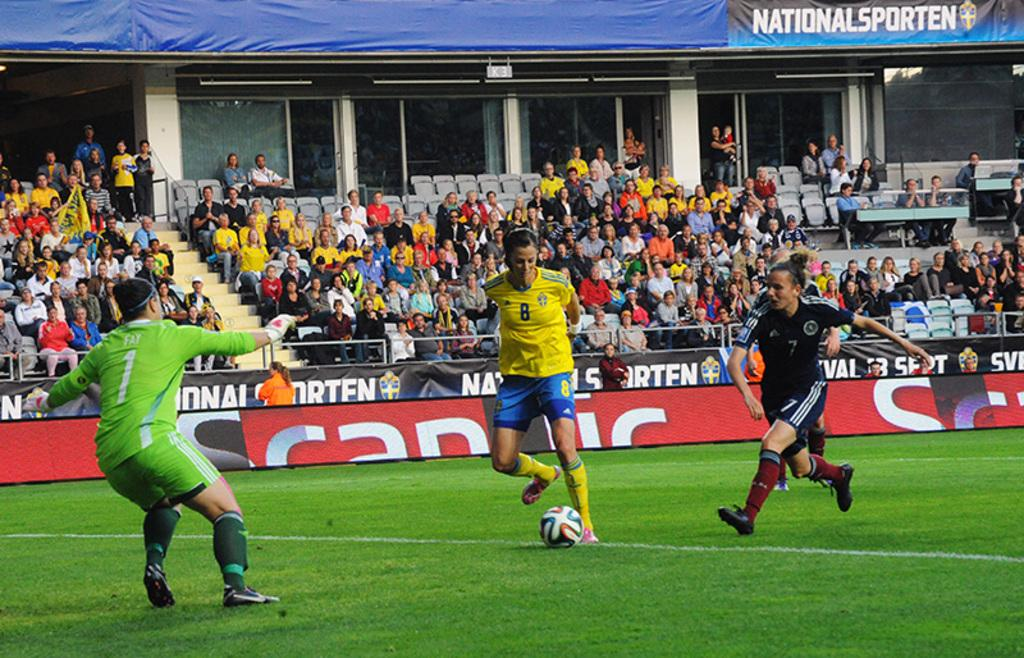<image>
Write a terse but informative summary of the picture. soccer players on a field in front of signs for National Sporten 